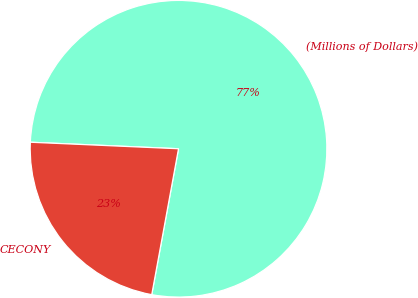<chart> <loc_0><loc_0><loc_500><loc_500><pie_chart><fcel>(Millions of Dollars)<fcel>CECONY<nl><fcel>77.19%<fcel>22.81%<nl></chart> 